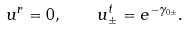Convert formula to latex. <formula><loc_0><loc_0><loc_500><loc_500>u ^ { r } = 0 , \quad u ^ { t } _ { \pm } = e ^ { - \gamma _ { 0 \pm } } .</formula> 